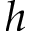Convert formula to latex. <formula><loc_0><loc_0><loc_500><loc_500>h</formula> 